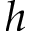Convert formula to latex. <formula><loc_0><loc_0><loc_500><loc_500>h</formula> 